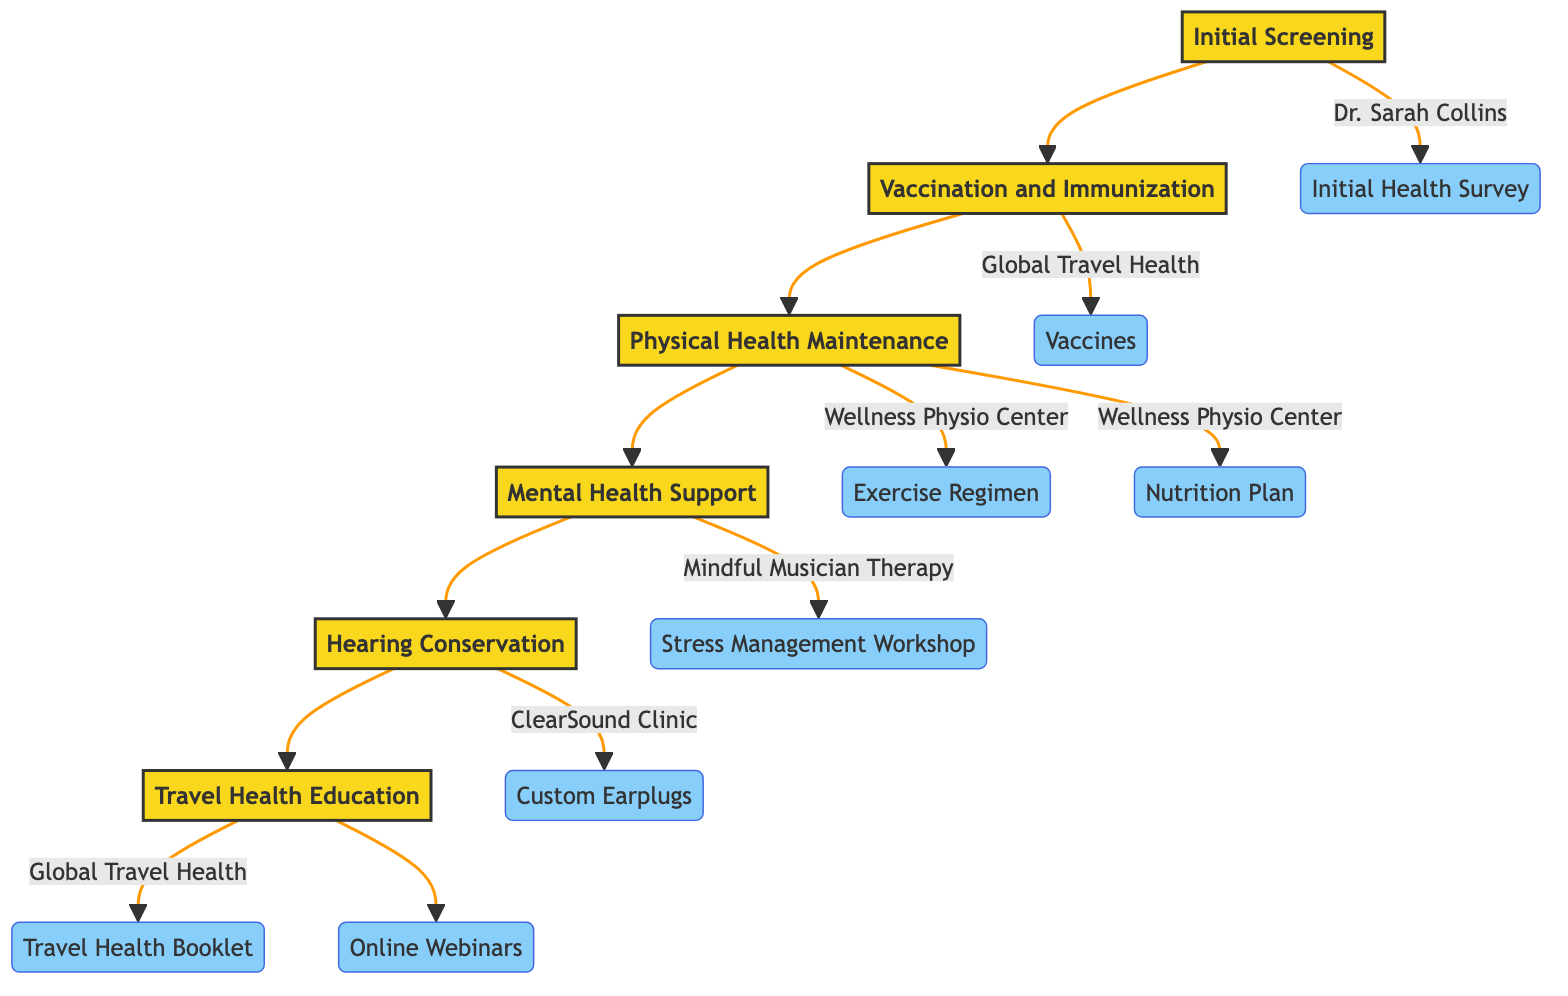What is the first step in the clinical pathway? The diagram shows that the first step in the clinical pathway is "Initial Screening". This is the starting point and can be visualized at the top of the flow.
Answer: Initial Screening Who conducts the "Vaccination and Immunization"? The diagram indicates that "Global Travel Health" conducts the "Vaccination and Immunization". This is shown as an entity that connects to that step.
Answer: Global Travel Health How many steps are there in total? By counting the steps in the diagram (Initial Screening, Vaccination and Immunization, Physical Health Maintenance, Mental Health Support, Hearing Conservation, and Travel Health Education), there are six distinct steps in the clinical pathway.
Answer: Six What entity is associated with "Mental Health Support"? According to the diagram, "Mindful Musician Therapy" is the associated entity for "Mental Health Support". This connection is explicitly shown in the chart.
Answer: Mindful Musician Therapy What are the two entities involved in "Physical Health Maintenance"? The diagram identifies two entities linked to "Physical Health Maintenance": "Wellness Physio Center" and the two specific plans: "Exercise Regimen" and "Nutrition Plan". It shows that both are integral parts of maintaining physical health.
Answer: Wellness Physio Center, Exercise Regimen, Nutrition Plan Which step follows "Hearing Conservation"? The flow in the diagram shows that after "Hearing Conservation", the subsequent step is "Travel Health Education". This is indicated by the directional flow from the hearing conservation step to the travel health education step.
Answer: Travel Health Education What is the purpose of the "Travel Health Booklet"? The diagram indicates that the "Travel Health Booklet" is a resource provided under the "Travel Health Education" step. Its purpose is to help educate musicians on maintaining health while traveling.
Answer: Health education How many entities are associated with the "Vaccination and Immunization" step? There is a single entity associated with the "Vaccination and Immunization" step in the diagram, which is "Vaccines". This means it focuses specifically on travel-related vaccination needs.
Answer: One What type of services does "ClearSound Clinic" provide? Based on the diagram, "ClearSound Clinic" provides services related to "Hearing Conservation", specifically including regular hearing tests and preventive measures for hearing protection.
Answer: Hearing Conservation 